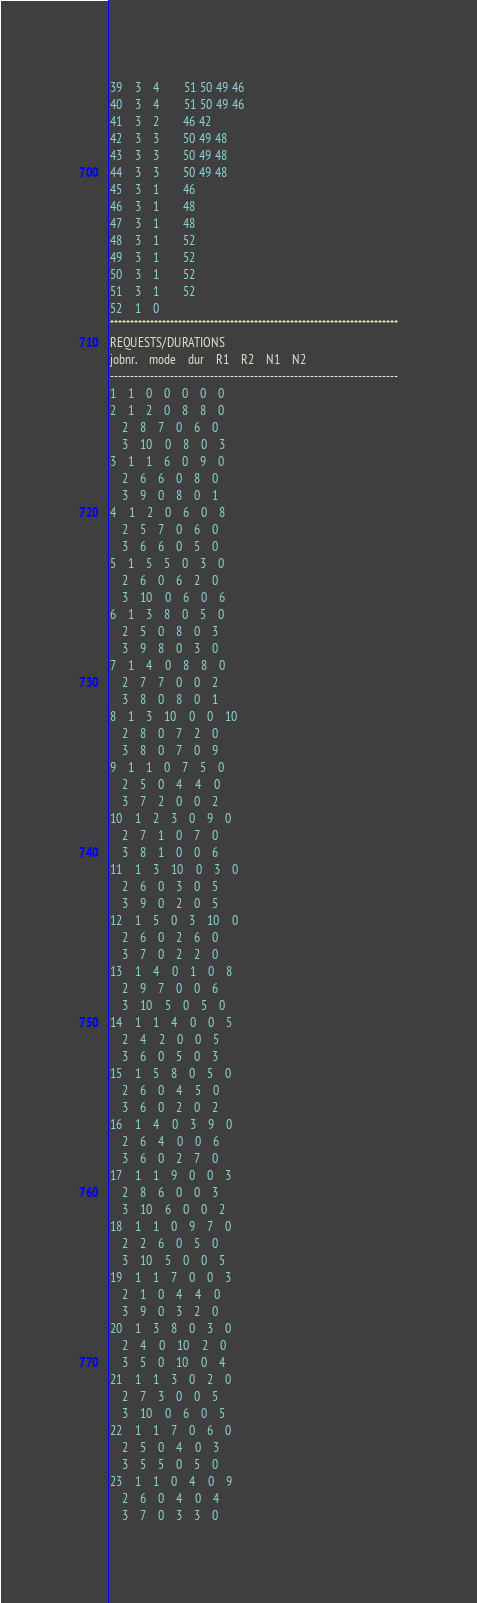Convert code to text. <code><loc_0><loc_0><loc_500><loc_500><_ObjectiveC_>39	3	4		51 50 49 46 
40	3	4		51 50 49 46 
41	3	2		46 42 
42	3	3		50 49 48 
43	3	3		50 49 48 
44	3	3		50 49 48 
45	3	1		46 
46	3	1		48 
47	3	1		48 
48	3	1		52 
49	3	1		52 
50	3	1		52 
51	3	1		52 
52	1	0		
************************************************************************
REQUESTS/DURATIONS
jobnr.	mode	dur	R1	R2	N1	N2	
------------------------------------------------------------------------
1	1	0	0	0	0	0	
2	1	2	0	8	8	0	
	2	8	7	0	6	0	
	3	10	0	8	0	3	
3	1	1	6	0	9	0	
	2	6	6	0	8	0	
	3	9	0	8	0	1	
4	1	2	0	6	0	8	
	2	5	7	0	6	0	
	3	6	6	0	5	0	
5	1	5	5	0	3	0	
	2	6	0	6	2	0	
	3	10	0	6	0	6	
6	1	3	8	0	5	0	
	2	5	0	8	0	3	
	3	9	8	0	3	0	
7	1	4	0	8	8	0	
	2	7	7	0	0	2	
	3	8	0	8	0	1	
8	1	3	10	0	0	10	
	2	8	0	7	2	0	
	3	8	0	7	0	9	
9	1	1	0	7	5	0	
	2	5	0	4	4	0	
	3	7	2	0	0	2	
10	1	2	3	0	9	0	
	2	7	1	0	7	0	
	3	8	1	0	0	6	
11	1	3	10	0	3	0	
	2	6	0	3	0	5	
	3	9	0	2	0	5	
12	1	5	0	3	10	0	
	2	6	0	2	6	0	
	3	7	0	2	2	0	
13	1	4	0	1	0	8	
	2	9	7	0	0	6	
	3	10	5	0	5	0	
14	1	1	4	0	0	5	
	2	4	2	0	0	5	
	3	6	0	5	0	3	
15	1	5	8	0	5	0	
	2	6	0	4	5	0	
	3	6	0	2	0	2	
16	1	4	0	3	9	0	
	2	6	4	0	0	6	
	3	6	0	2	7	0	
17	1	1	9	0	0	3	
	2	8	6	0	0	3	
	3	10	6	0	0	2	
18	1	1	0	9	7	0	
	2	2	6	0	5	0	
	3	10	5	0	0	5	
19	1	1	7	0	0	3	
	2	1	0	4	4	0	
	3	9	0	3	2	0	
20	1	3	8	0	3	0	
	2	4	0	10	2	0	
	3	5	0	10	0	4	
21	1	1	3	0	2	0	
	2	7	3	0	0	5	
	3	10	0	6	0	5	
22	1	1	7	0	6	0	
	2	5	0	4	0	3	
	3	5	5	0	5	0	
23	1	1	0	4	0	9	
	2	6	0	4	0	4	
	3	7	0	3	3	0	</code> 